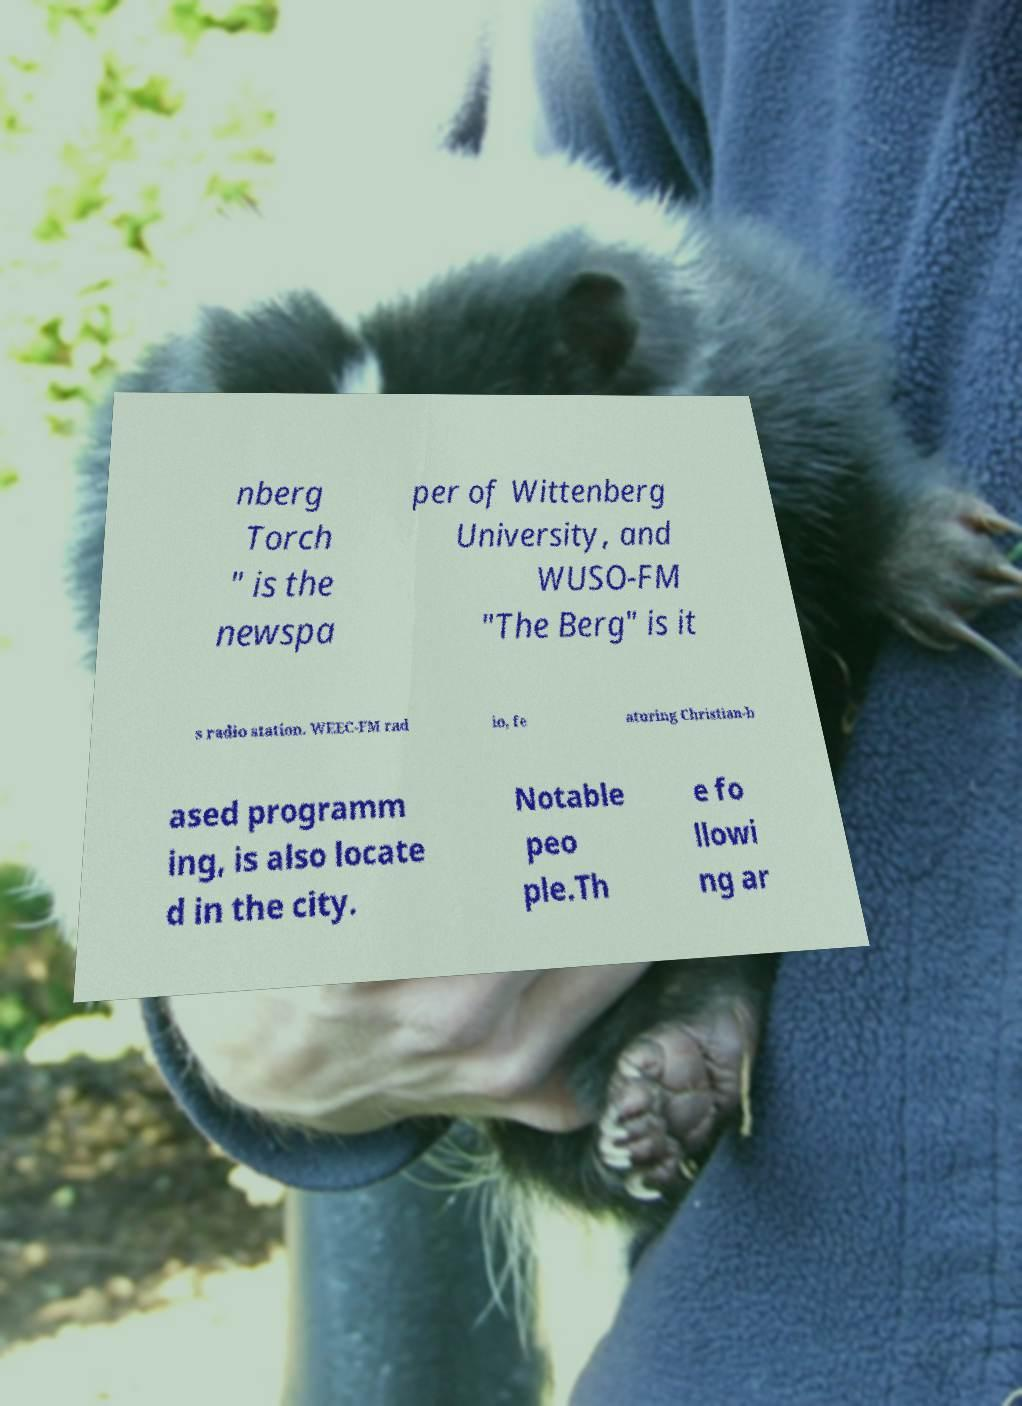Could you extract and type out the text from this image? nberg Torch " is the newspa per of Wittenberg University, and WUSO-FM "The Berg" is it s radio station. WEEC-FM rad io, fe aturing Christian-b ased programm ing, is also locate d in the city. Notable peo ple.Th e fo llowi ng ar 